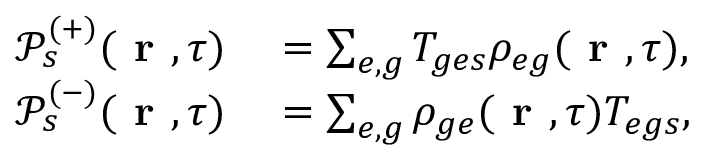<formula> <loc_0><loc_0><loc_500><loc_500>\begin{array} { r l } { \mathcal { P } _ { s } ^ { ( + ) } ( r , \tau ) } & = \sum _ { e , g } T _ { g e s } \rho _ { e g } ( r , \tau ) , } \\ { \mathcal { P } _ { s } ^ { ( - ) } ( r , \tau ) } & = \sum _ { e , g } \rho _ { g e } ( r , \tau ) T _ { e g s } , } \end{array}</formula> 